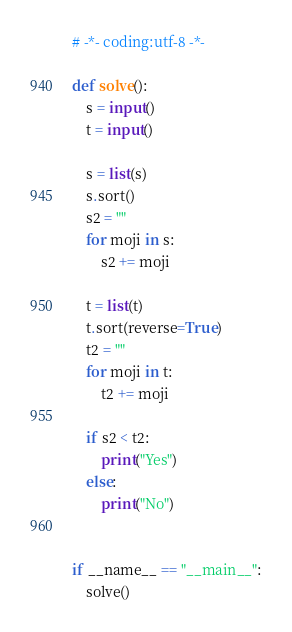<code> <loc_0><loc_0><loc_500><loc_500><_Python_># -*- coding:utf-8 -*-

def solve():
    s = input()
    t = input()

    s = list(s)
    s.sort()
    s2 = ""
    for moji in s:
        s2 += moji

    t = list(t)
    t.sort(reverse=True)
    t2 = ""
    for moji in t:
        t2 += moji
    
    if s2 < t2:
        print("Yes")
    else:
        print("No")


if __name__ == "__main__":
    solve()
</code> 